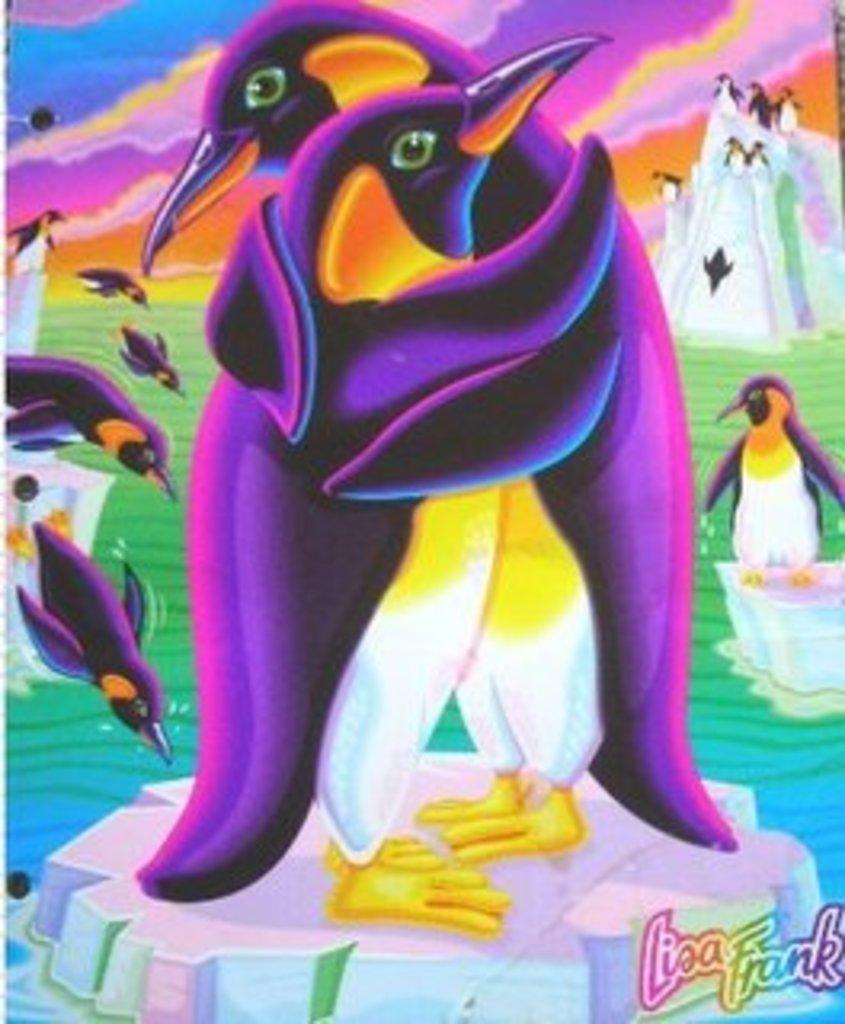What type of image is being described? The image is animated. What animals are present in the image? There are penguins in the image. What type of plantation can be seen in the image? There is no plantation present in the image; it features animated penguins. How do the penguins slip and stop in the image? The penguins do not slip or stop in the image, as it is an animated representation and not a real-life scenario. 